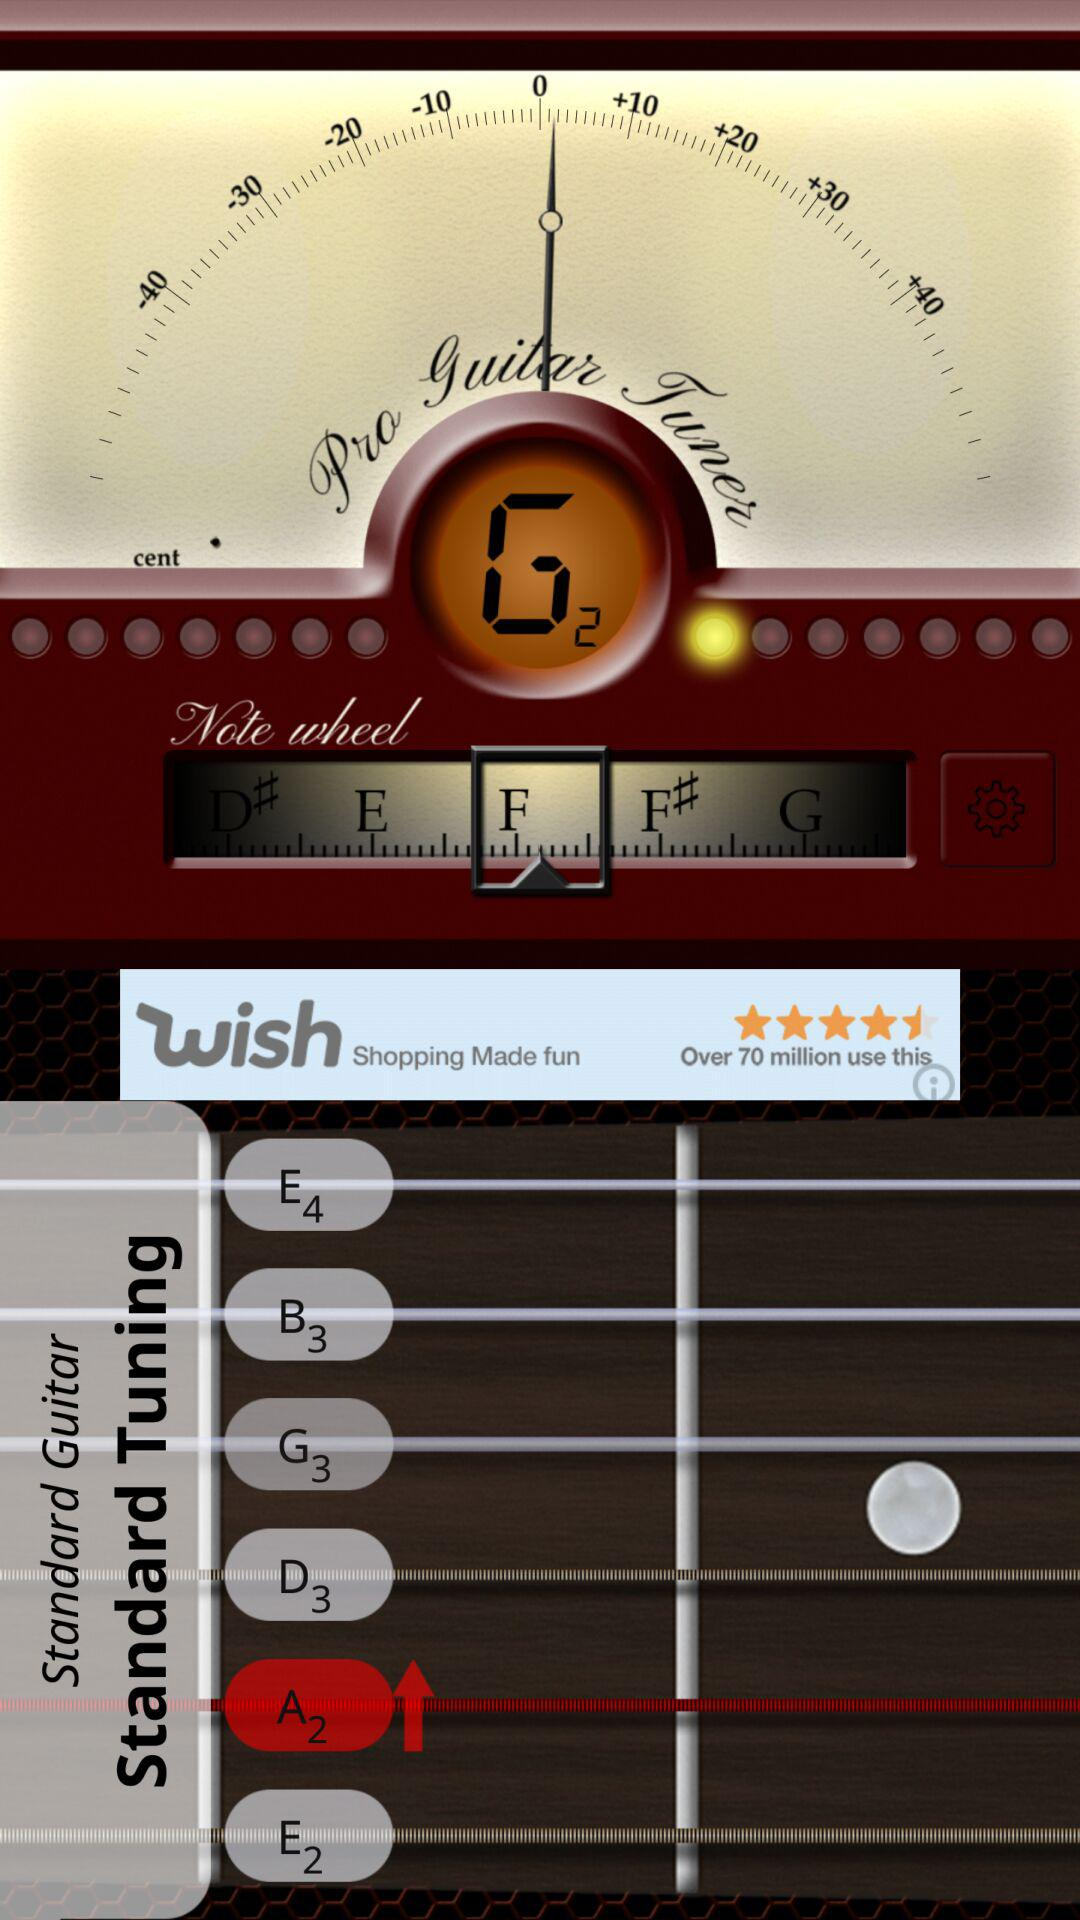How many notes are there in the standard guitar tuning?
Answer the question using a single word or phrase. 6 